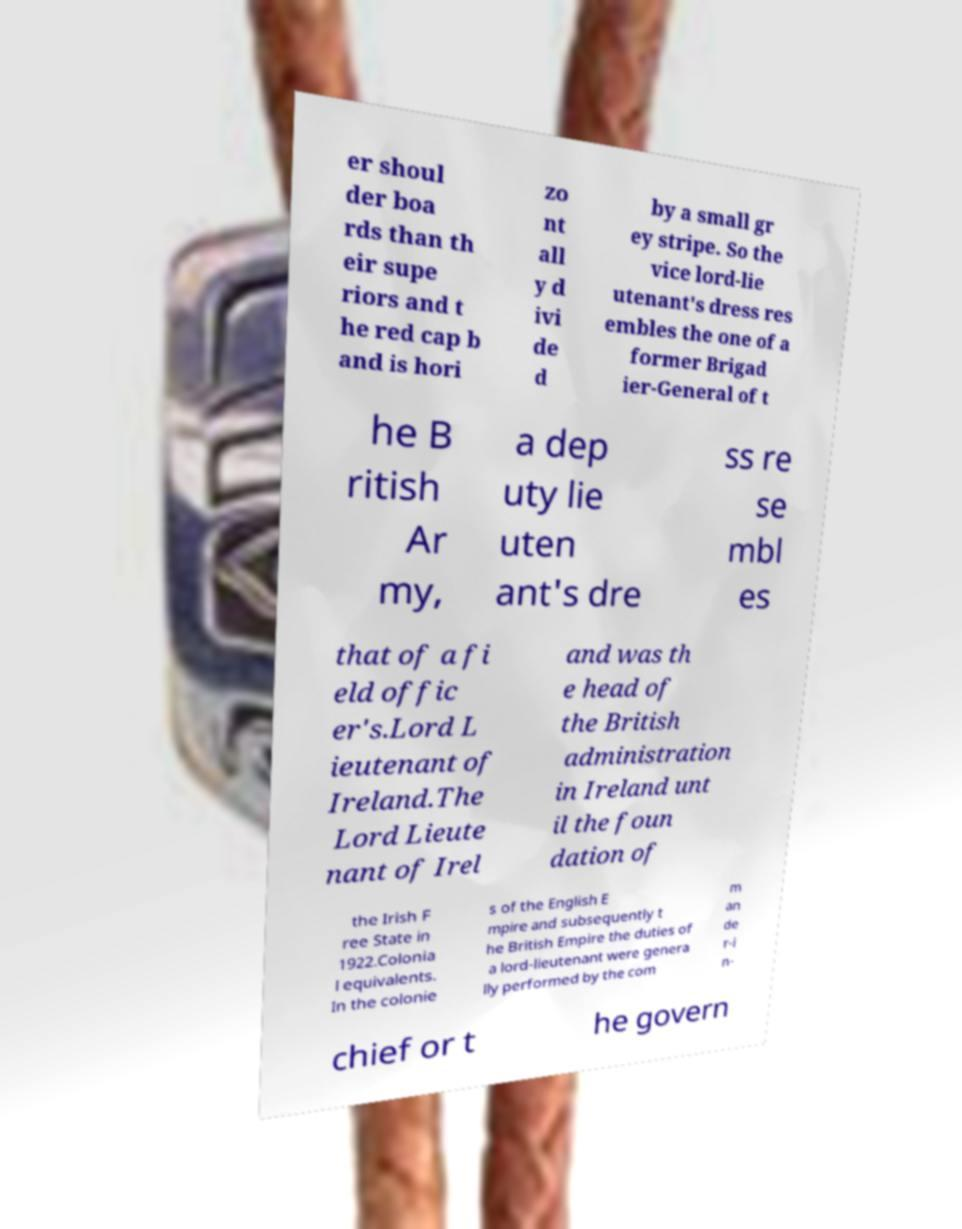I need the written content from this picture converted into text. Can you do that? er shoul der boa rds than th eir supe riors and t he red cap b and is hori zo nt all y d ivi de d by a small gr ey stripe. So the vice lord-lie utenant's dress res embles the one of a former Brigad ier-General of t he B ritish Ar my, a dep uty lie uten ant's dre ss re se mbl es that of a fi eld offic er's.Lord L ieutenant of Ireland.The Lord Lieute nant of Irel and was th e head of the British administration in Ireland unt il the foun dation of the Irish F ree State in 1922.Colonia l equivalents. In the colonie s of the English E mpire and subsequently t he British Empire the duties of a lord-lieutenant were genera lly performed by the com m an de r-i n- chief or t he govern 